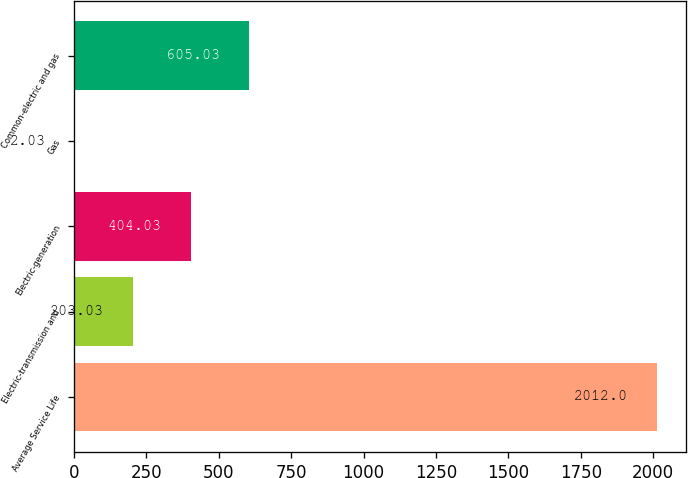<chart> <loc_0><loc_0><loc_500><loc_500><bar_chart><fcel>Average Service Life<fcel>Electric-transmission and<fcel>Electric-generation<fcel>Gas<fcel>Common-electric and gas<nl><fcel>2012<fcel>203.03<fcel>404.03<fcel>2.03<fcel>605.03<nl></chart> 